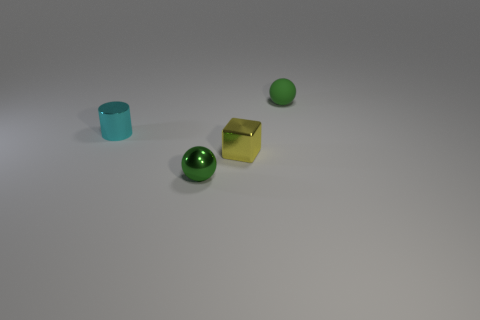Can you describe the surface on which the objects are placed? The surface appears to be a smooth, even, and light-colored plane, possibly a table or a floor, which provides a neutral background for the objects. 